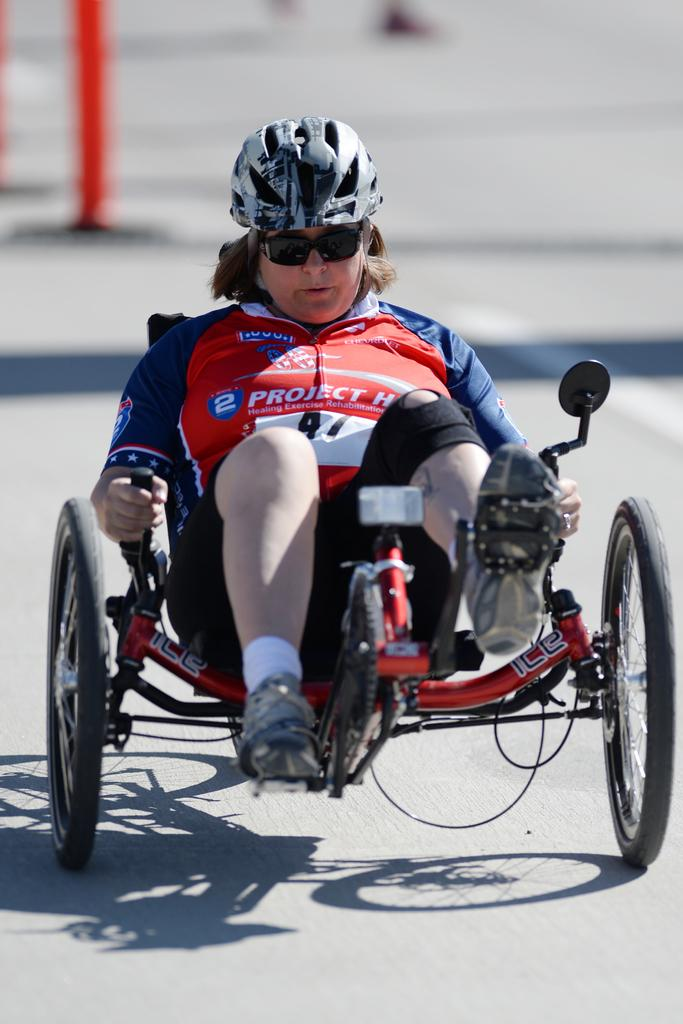What is the person in the image sitting on? There is a person sitting on a vehicle in the image. What is a characteristic of the vehicle? The vehicle has wheels. What type of protective gear is the person wearing? The person is wearing a helmet. What else is the person wearing that might be used for eye protection? The person is wearing goggles. Where are the rabbits hiding in the image? There are no rabbits present in the image. How many giants can be seen in the image? There are no giants present in the image. What type of tool is the person using to rake the ground in the image? There is no rake or any indication of ground raking in the image. 